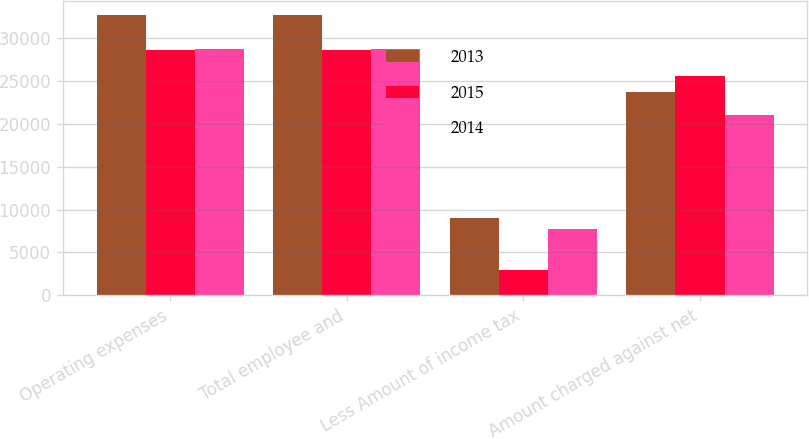Convert chart to OTSL. <chart><loc_0><loc_0><loc_500><loc_500><stacked_bar_chart><ecel><fcel>Operating expenses<fcel>Total employee and<fcel>Less Amount of income tax<fcel>Amount charged against net<nl><fcel>2013<fcel>32719<fcel>32719<fcel>9058<fcel>23661<nl><fcel>2015<fcel>28552<fcel>28552<fcel>2932<fcel>25620<nl><fcel>2014<fcel>28764<fcel>28764<fcel>7730<fcel>21034<nl></chart> 